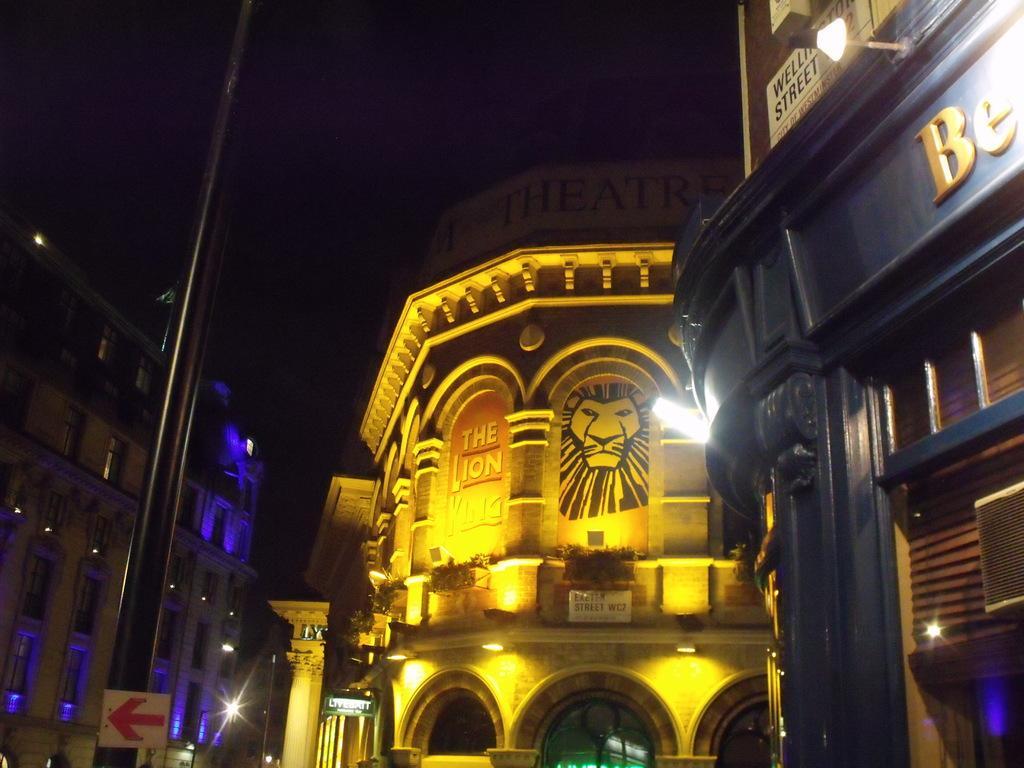Describe this image in one or two sentences. This image is taken during the night time. In this image we can see that there is a building in the middle. On the right side there is another building. On the left side there is a pole to which there is a directional board. At the bottom there are lights which are attached to the building. 